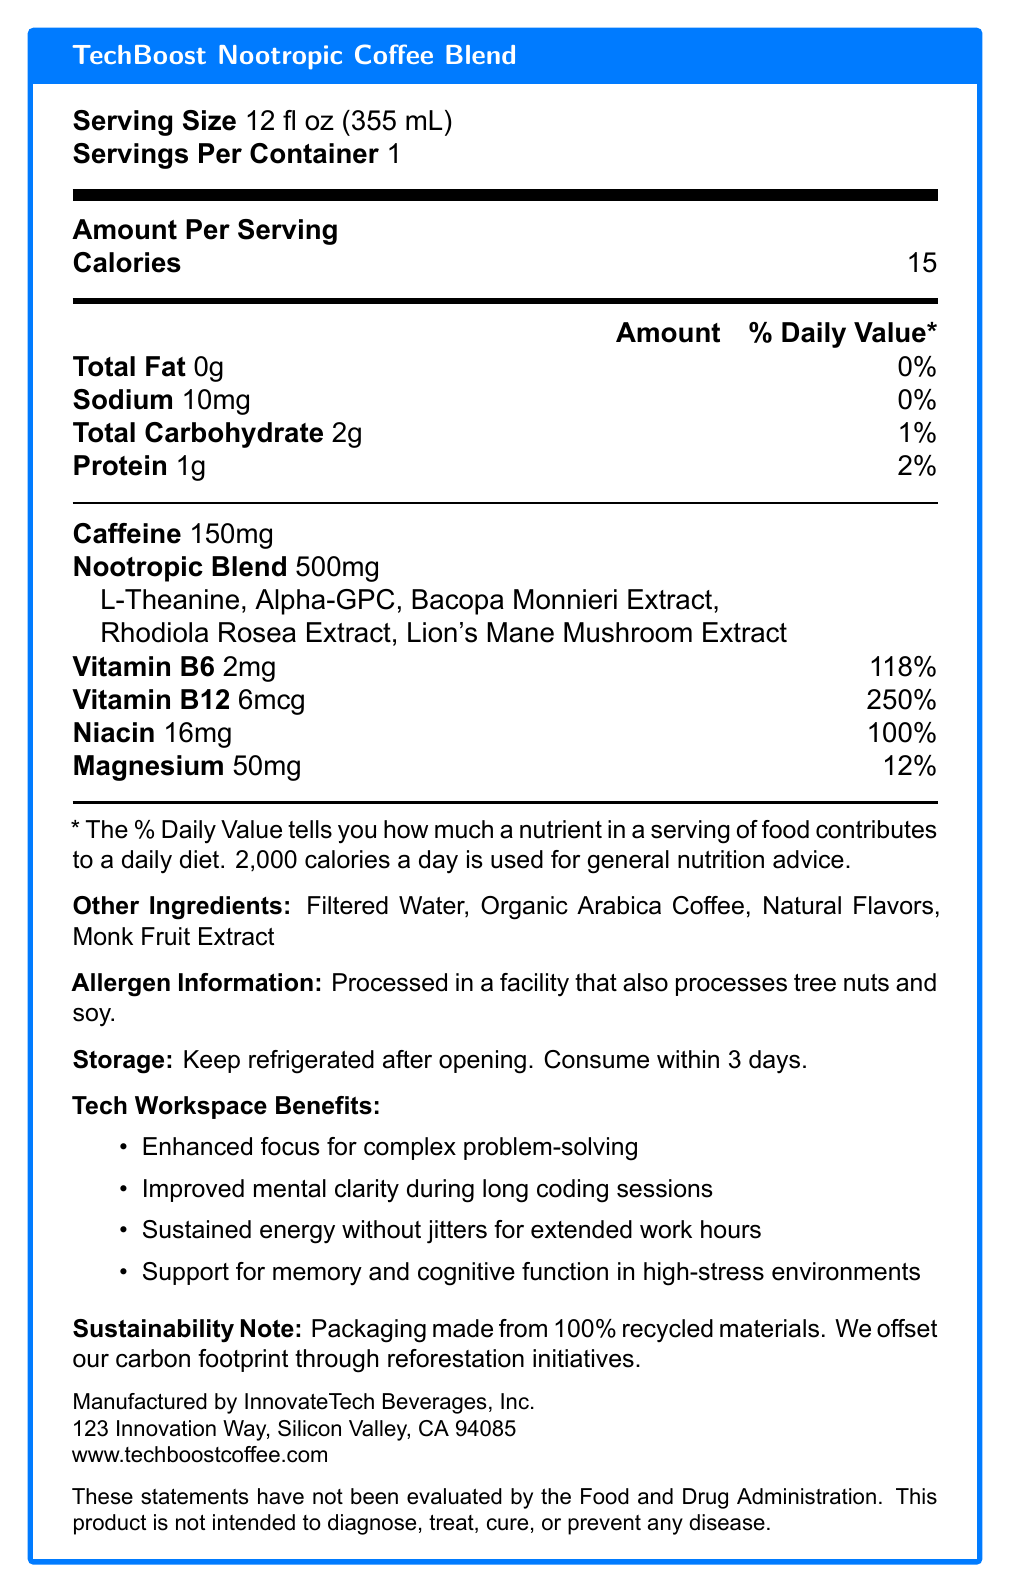how many calories are in one serving? The document specifies that there are 15 calories per serving in the "Amount Per Serving" section.
Answer: 15 what is the serving size of the TechBoost Nootropic Coffee Blend? The serving size is listed as 12 fl oz (355 mL) right at the top of the document.
Answer: 12 fl oz (355 mL) how many grams of protein does the coffee blend contain? The protein amount per serving is listed as 1g in the section that breaks down nutrients.
Answer: 1g what is the sodium content in the coffee blend? The sodium content per serving is given as 10mg in the nutrient breakdown section.
Answer: 10mg name one benefit of consuming the TechBoost Nootropic Coffee Blend in a tech workspace. The document lists several benefits, including "Enhanced focus for complex problem-solving."
Answer: Enhanced focus for complex problem-solving which vitamins and minerals are included in the coffee blend? A. Vitamin A, Vitamin C B. Vitamin B6, Vitamin B12, Niacin, Magnesium C. Vitamin D, Calcium The vitamins and minerals listed in the document are Vitamin B6, Vitamin B12, Niacin, and Magnesium.
Answer: B. Vitamin B6, Vitamin B12, Niacin, Magnesium what is the amount of caffeine in one serving of TechBoost Nootropic Coffee Blend? A. 100mg B. 200mg C. 150mg D. 50mg The document states that there are 150mg of caffeine per serving.
Answer: C. 150mg is the coffee blend processed in a facility that also processes nuts and soy? The allergen information section mentions that the product is processed in a facility that also processes tree nuts and soy.
Answer: Yes what are the other ingredients in the coffee blend besides the nootropic blend? These ingredients are listed under the "Other Ingredients" section.
Answer: Filtered Water, Organic Arabica Coffee, Natural Flavors, Monk Fruit Extract describe the main idea of the document. The document is comprehensive and includes multiple sections that cover various aspects of the product, from nutritional content to practical usage instructions and benefits.
Answer: The document provides detailed nutrition facts and additional information about the TechBoost Nootropic Coffee Blend, which is designed to enhance cognitive performance in a high-tech workspace. It lists the serving size, calories, nutrient content, nootropic ingredients, and benefits such as enhanced focus and mental clarity. It also mentions storage instructions, allergen information, and the company's sustainability initiatives. does the document specify the source of the nootropic ingredients? The document lists the nootropic ingredients but does not specify their sources.
Answer: No 